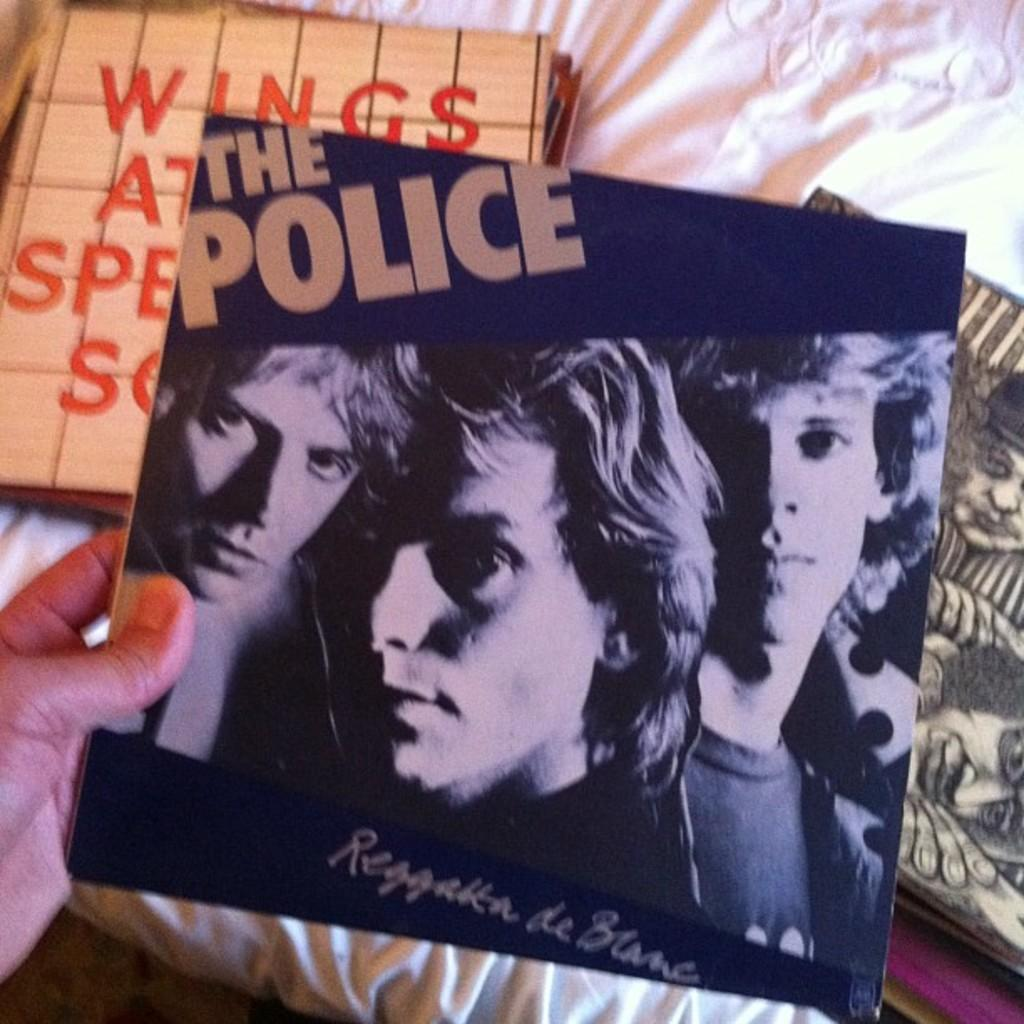What type of items can be seen in the image? There are albums in the image. How is one of the albums being held in the image? A hand is holding an album on the left side of the image. What can be observed on the cover page of the album? The album has a cover page with a person and some text. What type of range can be seen in the background of the image? There is no range present in the image; it features albums and a hand holding one of them. 